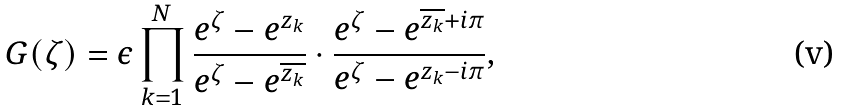Convert formula to latex. <formula><loc_0><loc_0><loc_500><loc_500>G ( \zeta ) = \epsilon \prod _ { k = 1 } ^ { N } \frac { e ^ { \zeta } - e ^ { z _ { k } } } { e ^ { \zeta } - e ^ { \overline { z _ { k } } } } \cdot \frac { e ^ { \zeta } - e ^ { \overline { z _ { k } } + i \pi } } { e ^ { \zeta } - e ^ { z _ { k } - i \pi } } ,</formula> 